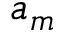<formula> <loc_0><loc_0><loc_500><loc_500>a _ { m }</formula> 